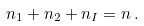<formula> <loc_0><loc_0><loc_500><loc_500>n _ { 1 } + n _ { 2 } + n _ { I } = n \, .</formula> 